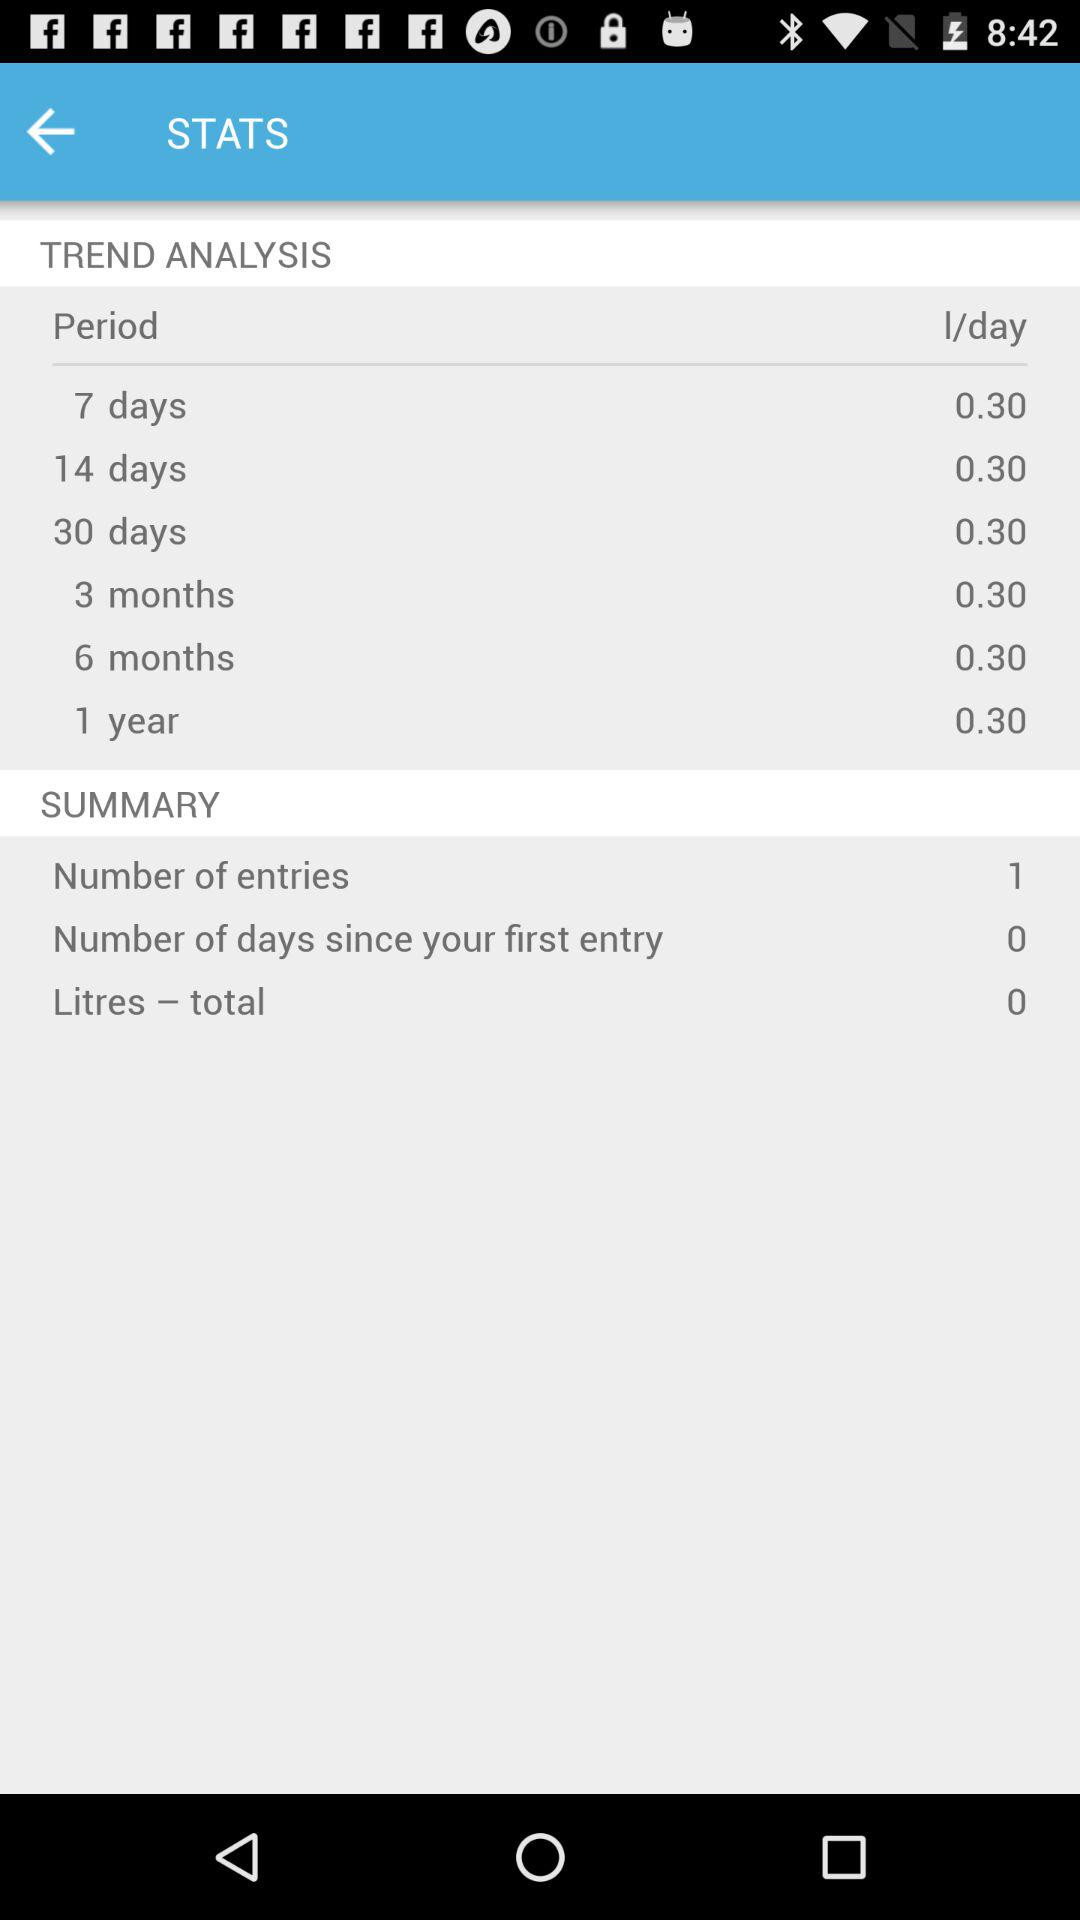What is the total number of entries? The total number of entries is 1. 